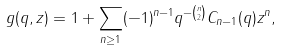<formula> <loc_0><loc_0><loc_500><loc_500>g ( q , z ) = 1 + \sum _ { n \geq 1 } ( - 1 ) ^ { n - 1 } q ^ { - \binom { n } { 2 } } C _ { n - 1 } ( q ) z ^ { n } ,</formula> 